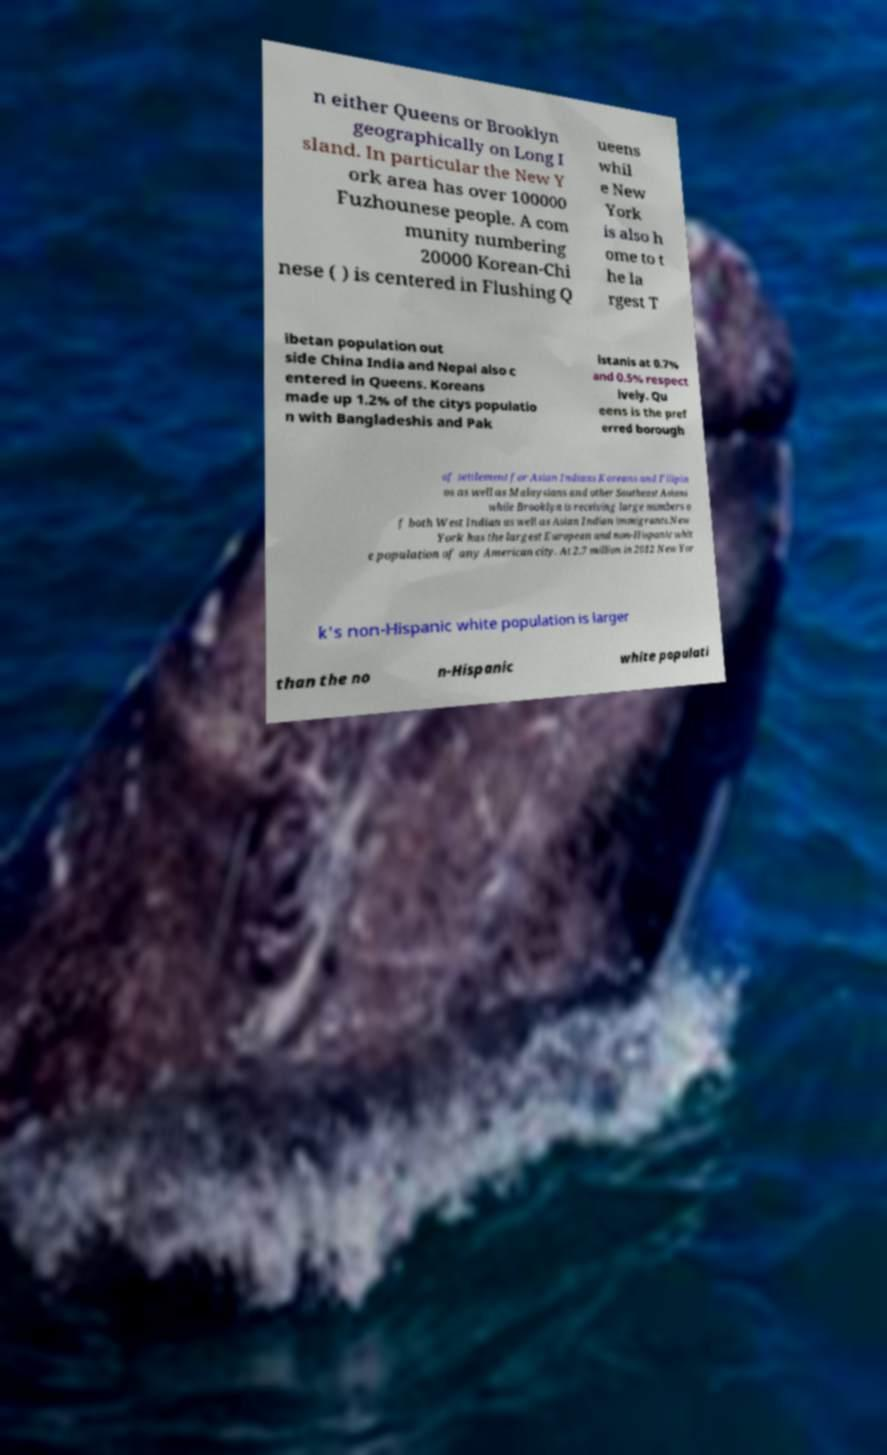For documentation purposes, I need the text within this image transcribed. Could you provide that? n either Queens or Brooklyn geographically on Long I sland. In particular the New Y ork area has over 100000 Fuzhounese people. A com munity numbering 20000 Korean-Chi nese ( ) is centered in Flushing Q ueens whil e New York is also h ome to t he la rgest T ibetan population out side China India and Nepal also c entered in Queens. Koreans made up 1.2% of the citys populatio n with Bangladeshis and Pak istanis at 0.7% and 0.5% respect ively. Qu eens is the pref erred borough of settlement for Asian Indians Koreans and Filipin os as well as Malaysians and other Southeast Asians while Brooklyn is receiving large numbers o f both West Indian as well as Asian Indian immigrants.New York has the largest European and non-Hispanic whit e population of any American city. At 2.7 million in 2012 New Yor k's non-Hispanic white population is larger than the no n-Hispanic white populati 